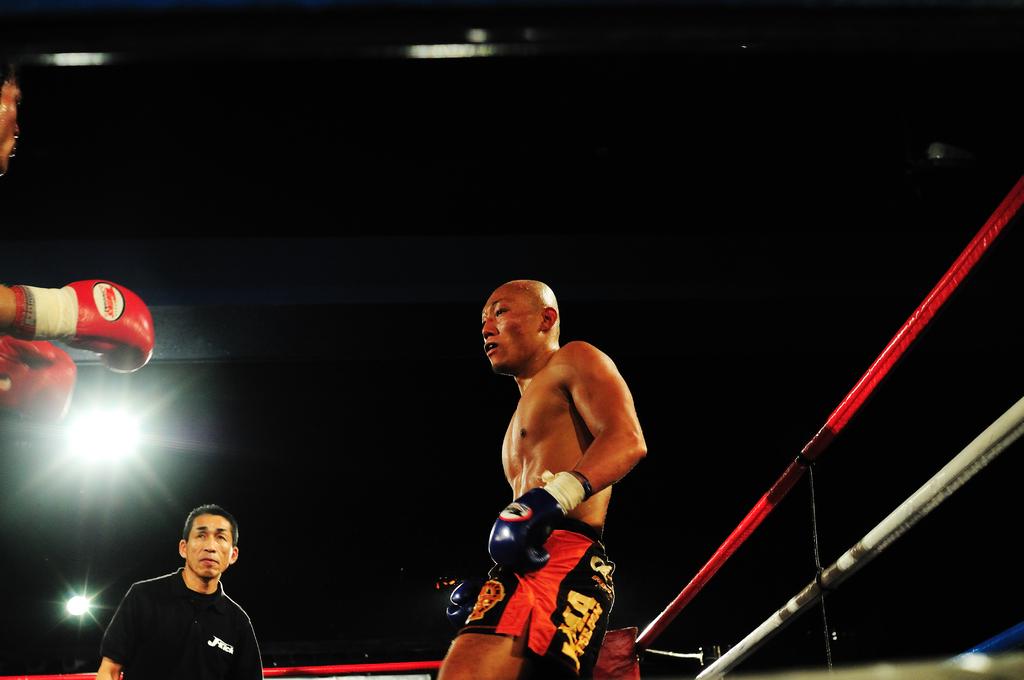What is printed on the black shirt?
Ensure brevity in your answer.  J-kick. 